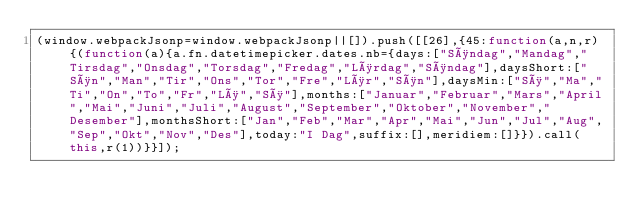Convert code to text. <code><loc_0><loc_0><loc_500><loc_500><_JavaScript_>(window.webpackJsonp=window.webpackJsonp||[]).push([[26],{45:function(a,n,r){(function(a){a.fn.datetimepicker.dates.nb={days:["Søndag","Mandag","Tirsdag","Onsdag","Torsdag","Fredag","Lørdag","Søndag"],daysShort:["Søn","Man","Tir","Ons","Tor","Fre","Lør","Søn"],daysMin:["Sø","Ma","Ti","On","To","Fr","Lø","Sø"],months:["Januar","Februar","Mars","April","Mai","Juni","Juli","August","September","Oktober","November","Desember"],monthsShort:["Jan","Feb","Mar","Apr","Mai","Jun","Jul","Aug","Sep","Okt","Nov","Des"],today:"I Dag",suffix:[],meridiem:[]}}).call(this,r(1))}}]);</code> 